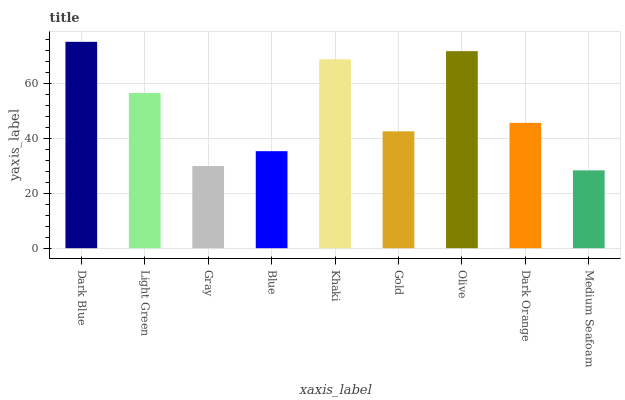Is Medium Seafoam the minimum?
Answer yes or no. Yes. Is Dark Blue the maximum?
Answer yes or no. Yes. Is Light Green the minimum?
Answer yes or no. No. Is Light Green the maximum?
Answer yes or no. No. Is Dark Blue greater than Light Green?
Answer yes or no. Yes. Is Light Green less than Dark Blue?
Answer yes or no. Yes. Is Light Green greater than Dark Blue?
Answer yes or no. No. Is Dark Blue less than Light Green?
Answer yes or no. No. Is Dark Orange the high median?
Answer yes or no. Yes. Is Dark Orange the low median?
Answer yes or no. Yes. Is Dark Blue the high median?
Answer yes or no. No. Is Gold the low median?
Answer yes or no. No. 